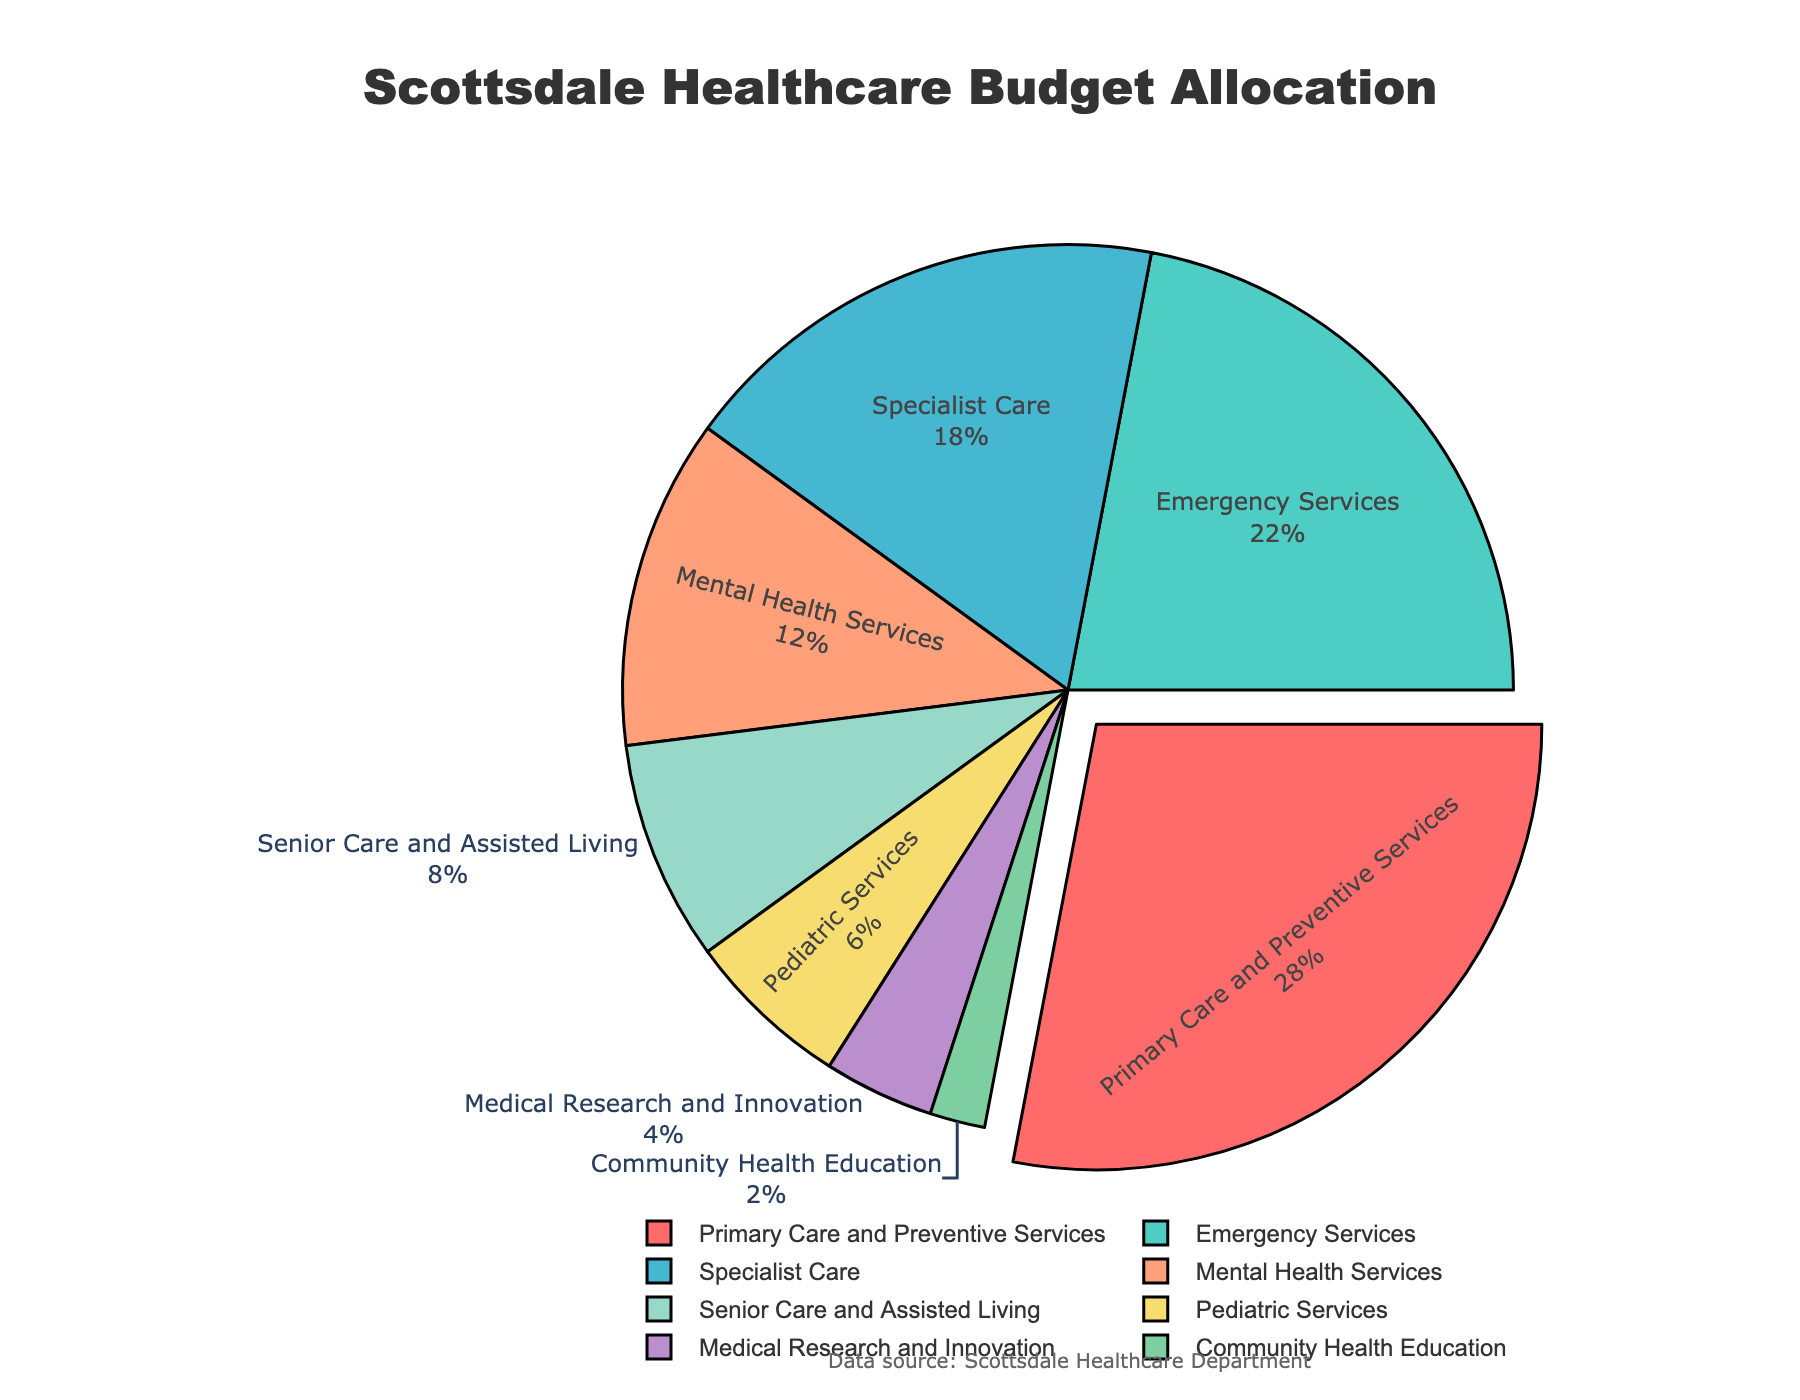What's the largest sector in Scottsdale's healthcare budget allocation? The largest sector is identified by finding the segment with the highest percentage. In the figure, "Primary Care and Preventive Services" occupies the largest portion.
Answer: Primary Care and Preventive Services How much larger is the budget allocation for Emergency Services compared to Pediatric Services? Identify the percentages for Emergency Services (22%) and Pediatric Services (6%) and subtract the latter from the former: 22% - 6% = 16%.
Answer: 16% Which sector accounts for more budget allocation, Mental Health Services or Senior Care and Assisted Living? Look at the percentages for both sectors: Mental Health Services has a 12% allocation, while Senior Care and Assisted Living has an 8% allocation. 12% is greater than 8%.
Answer: Mental Health Services What is the combined budget allocation for Specialist Care and Medical Research and Innovation? Identify the percentages for Specialist Care (18%) and Medical Research and Innovation (4%), then sum them up: 18% + 4% = 22%.
Answer: 22% What proportion of the budget is allocated to sectors other than Primary Care and Preventive Services? Subtract the percentage of Primary Care and Preventive Services (28%) from 100%: 100% - 28% = 72%.
Answer: 72% Is the budget allocation for Community Health Education greater or smaller than that for Pediatric Services? Compare the percentages: Community Health Education has 2%, while Pediatric Services has 6%. 2% is smaller than 6%.
Answer: Smaller By how much does the percentage allocation for Specialist Care exceed that for Mental Health Services? Identify the percentages for Specialist Care (18%) and Mental Health Services (12%), then subtract the latter from the former: 18% - 12% = 6%.
Answer: 6% Which sector has the smallest budget allocation, and what is its value? Identify the sector with the smallest segment in the pie chart, which is Community Health Education, and the value is 2%.
Answer: Community Health Education, 2% What is the total budget share allocated to Primary Care and Preventive Services, and Pediatric Services combined? Add the percentages for Primary Care and Preventive Services (28%) and Pediatric Services (6%): 28% + 6% = 34%.
Answer: 34% If the budget for Emergency Services were increased by 5%, what would its new budget allocation be? Add 5% to the current Emergency Services allocation: 22% + 5% = 27%.
Answer: 27% 